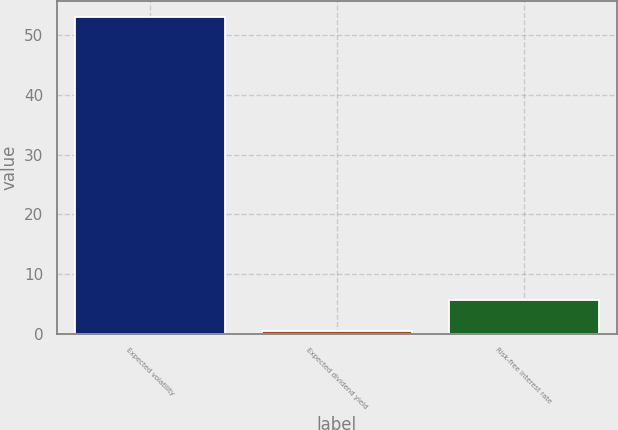<chart> <loc_0><loc_0><loc_500><loc_500><bar_chart><fcel>Expected volatility<fcel>Expected dividend yield<fcel>Risk-free interest rate<nl><fcel>53<fcel>0.46<fcel>5.71<nl></chart> 